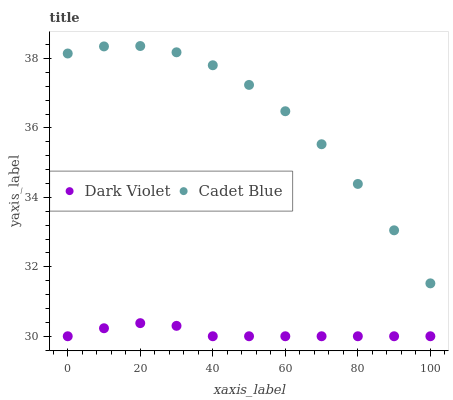Does Dark Violet have the minimum area under the curve?
Answer yes or no. Yes. Does Cadet Blue have the maximum area under the curve?
Answer yes or no. Yes. Does Dark Violet have the maximum area under the curve?
Answer yes or no. No. Is Dark Violet the smoothest?
Answer yes or no. Yes. Is Cadet Blue the roughest?
Answer yes or no. Yes. Is Dark Violet the roughest?
Answer yes or no. No. Does Dark Violet have the lowest value?
Answer yes or no. Yes. Does Cadet Blue have the highest value?
Answer yes or no. Yes. Does Dark Violet have the highest value?
Answer yes or no. No. Is Dark Violet less than Cadet Blue?
Answer yes or no. Yes. Is Cadet Blue greater than Dark Violet?
Answer yes or no. Yes. Does Dark Violet intersect Cadet Blue?
Answer yes or no. No. 